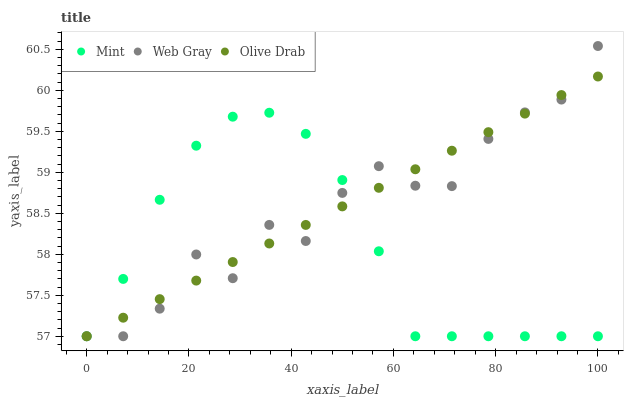Does Mint have the minimum area under the curve?
Answer yes or no. Yes. Does Olive Drab have the maximum area under the curve?
Answer yes or no. Yes. Does Olive Drab have the minimum area under the curve?
Answer yes or no. No. Does Mint have the maximum area under the curve?
Answer yes or no. No. Is Olive Drab the smoothest?
Answer yes or no. Yes. Is Web Gray the roughest?
Answer yes or no. Yes. Is Mint the smoothest?
Answer yes or no. No. Is Mint the roughest?
Answer yes or no. No. Does Web Gray have the lowest value?
Answer yes or no. Yes. Does Web Gray have the highest value?
Answer yes or no. Yes. Does Olive Drab have the highest value?
Answer yes or no. No. Does Mint intersect Olive Drab?
Answer yes or no. Yes. Is Mint less than Olive Drab?
Answer yes or no. No. Is Mint greater than Olive Drab?
Answer yes or no. No. 